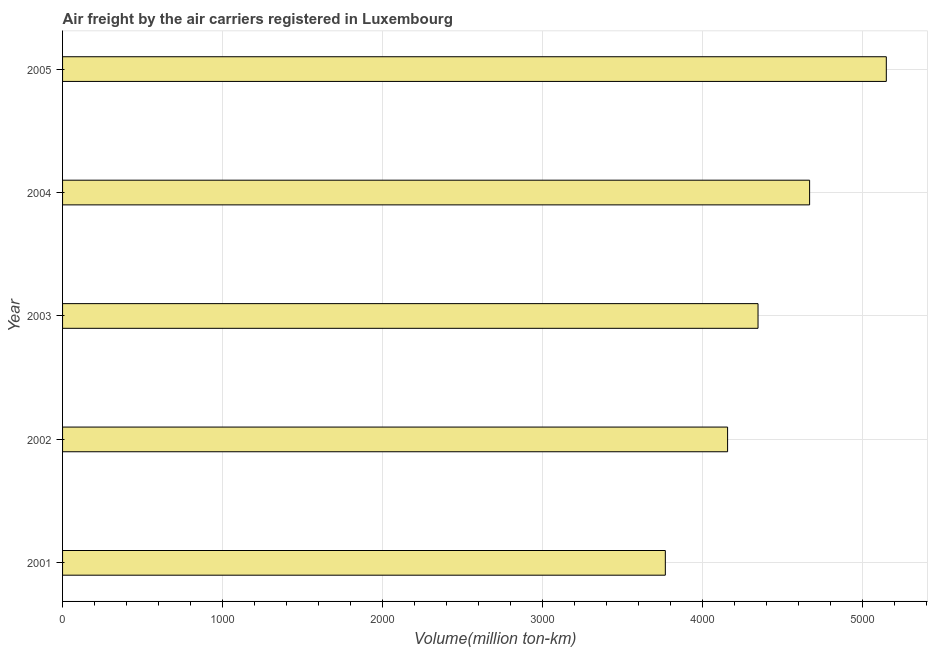Does the graph contain any zero values?
Offer a terse response. No. What is the title of the graph?
Your answer should be compact. Air freight by the air carriers registered in Luxembourg. What is the label or title of the X-axis?
Offer a very short reply. Volume(million ton-km). What is the air freight in 2001?
Your answer should be very brief. 3768.19. Across all years, what is the maximum air freight?
Give a very brief answer. 5149.69. Across all years, what is the minimum air freight?
Offer a terse response. 3768.19. In which year was the air freight maximum?
Give a very brief answer. 2005. What is the sum of the air freight?
Give a very brief answer. 2.21e+04. What is the difference between the air freight in 2001 and 2002?
Offer a very short reply. -389.33. What is the average air freight per year?
Your response must be concise. 4418.68. What is the median air freight?
Offer a terse response. 4347.78. What is the ratio of the air freight in 2002 to that in 2004?
Give a very brief answer. 0.89. Is the difference between the air freight in 2002 and 2003 greater than the difference between any two years?
Ensure brevity in your answer.  No. What is the difference between the highest and the second highest air freight?
Give a very brief answer. 479.48. What is the difference between the highest and the lowest air freight?
Your response must be concise. 1381.5. In how many years, is the air freight greater than the average air freight taken over all years?
Ensure brevity in your answer.  2. How many bars are there?
Your answer should be very brief. 5. How many years are there in the graph?
Your answer should be compact. 5. What is the Volume(million ton-km) of 2001?
Provide a succinct answer. 3768.19. What is the Volume(million ton-km) in 2002?
Ensure brevity in your answer.  4157.52. What is the Volume(million ton-km) in 2003?
Give a very brief answer. 4347.78. What is the Volume(million ton-km) in 2004?
Offer a terse response. 4670.21. What is the Volume(million ton-km) of 2005?
Provide a short and direct response. 5149.69. What is the difference between the Volume(million ton-km) in 2001 and 2002?
Your answer should be very brief. -389.33. What is the difference between the Volume(million ton-km) in 2001 and 2003?
Offer a terse response. -579.59. What is the difference between the Volume(million ton-km) in 2001 and 2004?
Your answer should be very brief. -902.02. What is the difference between the Volume(million ton-km) in 2001 and 2005?
Ensure brevity in your answer.  -1381.5. What is the difference between the Volume(million ton-km) in 2002 and 2003?
Your response must be concise. -190.27. What is the difference between the Volume(million ton-km) in 2002 and 2004?
Keep it short and to the point. -512.69. What is the difference between the Volume(million ton-km) in 2002 and 2005?
Your answer should be compact. -992.17. What is the difference between the Volume(million ton-km) in 2003 and 2004?
Ensure brevity in your answer.  -322.43. What is the difference between the Volume(million ton-km) in 2003 and 2005?
Offer a very short reply. -801.9. What is the difference between the Volume(million ton-km) in 2004 and 2005?
Provide a short and direct response. -479.48. What is the ratio of the Volume(million ton-km) in 2001 to that in 2002?
Give a very brief answer. 0.91. What is the ratio of the Volume(million ton-km) in 2001 to that in 2003?
Your answer should be very brief. 0.87. What is the ratio of the Volume(million ton-km) in 2001 to that in 2004?
Your response must be concise. 0.81. What is the ratio of the Volume(million ton-km) in 2001 to that in 2005?
Keep it short and to the point. 0.73. What is the ratio of the Volume(million ton-km) in 2002 to that in 2003?
Offer a very short reply. 0.96. What is the ratio of the Volume(million ton-km) in 2002 to that in 2004?
Provide a short and direct response. 0.89. What is the ratio of the Volume(million ton-km) in 2002 to that in 2005?
Keep it short and to the point. 0.81. What is the ratio of the Volume(million ton-km) in 2003 to that in 2005?
Your answer should be very brief. 0.84. What is the ratio of the Volume(million ton-km) in 2004 to that in 2005?
Give a very brief answer. 0.91. 